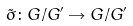<formula> <loc_0><loc_0><loc_500><loc_500>\tilde { \sigma } \colon G / G ^ { \prime } \rightarrow G / G ^ { \prime }</formula> 